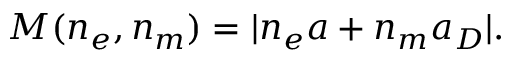<formula> <loc_0><loc_0><loc_500><loc_500>M ( n _ { e } , n _ { m } ) = | n _ { e } a + n _ { m } a _ { D } | .</formula> 